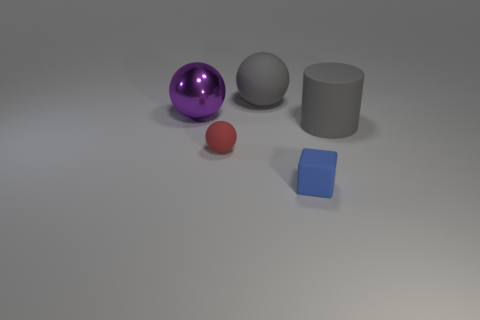Subtract all large balls. How many balls are left? 1 Subtract 1 balls. How many balls are left? 2 Add 2 gray shiny spheres. How many objects exist? 7 Subtract all blocks. How many objects are left? 4 Subtract 1 gray spheres. How many objects are left? 4 Subtract all gray matte objects. Subtract all yellow objects. How many objects are left? 3 Add 3 large purple spheres. How many large purple spheres are left? 4 Add 4 small blue rubber blocks. How many small blue rubber blocks exist? 5 